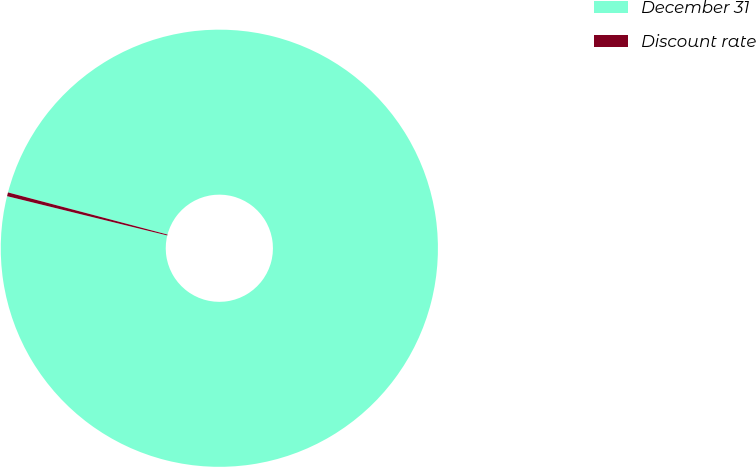Convert chart to OTSL. <chart><loc_0><loc_0><loc_500><loc_500><pie_chart><fcel>December 31<fcel>Discount rate<nl><fcel>99.72%<fcel>0.28%<nl></chart> 